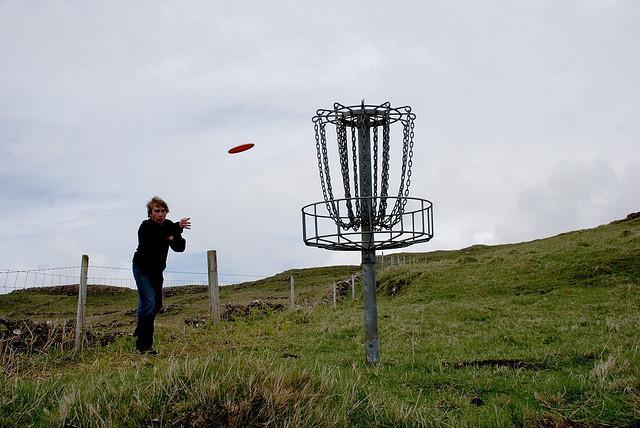What is in the air?
Concise answer only. Frisbee. Is the bicycle the main subject of the picture?
Be succinct. No. What game is this man playing?
Short answer required. Frisbee. What are those chains for?
Keep it brief. Catching frisbee. How many chains do you see?
Be succinct. 10. 